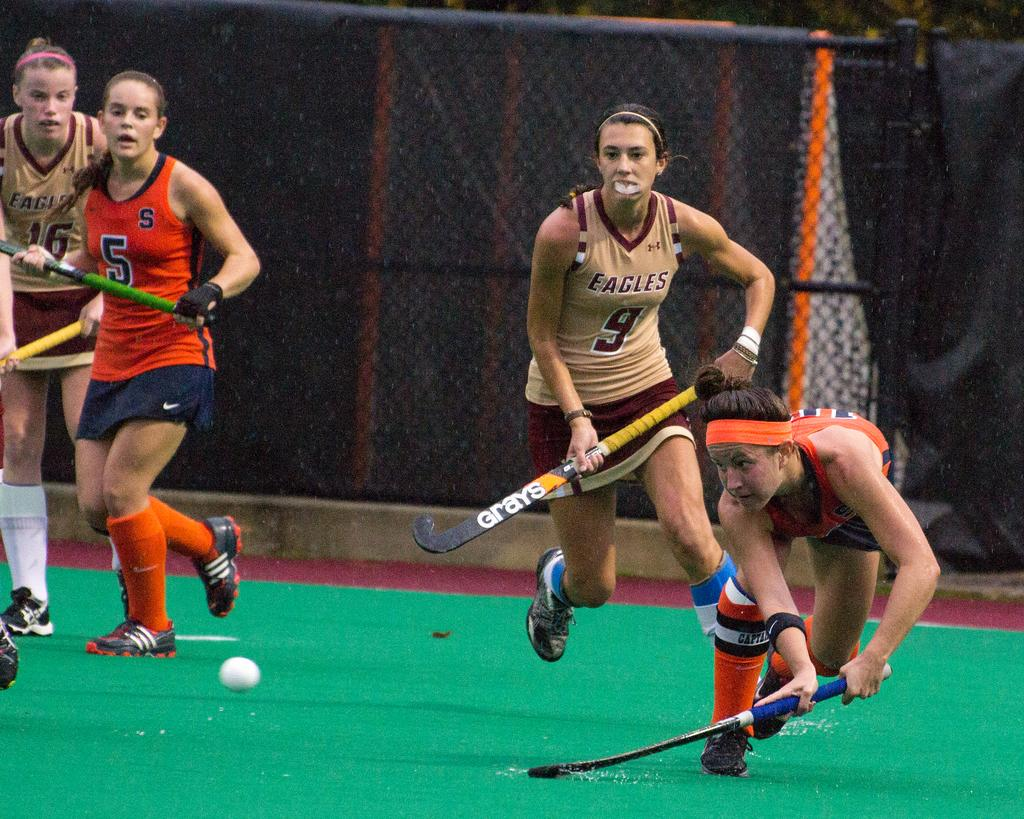Provide a one-sentence caption for the provided image. The Eagles compete against their opponents in an intense game. 